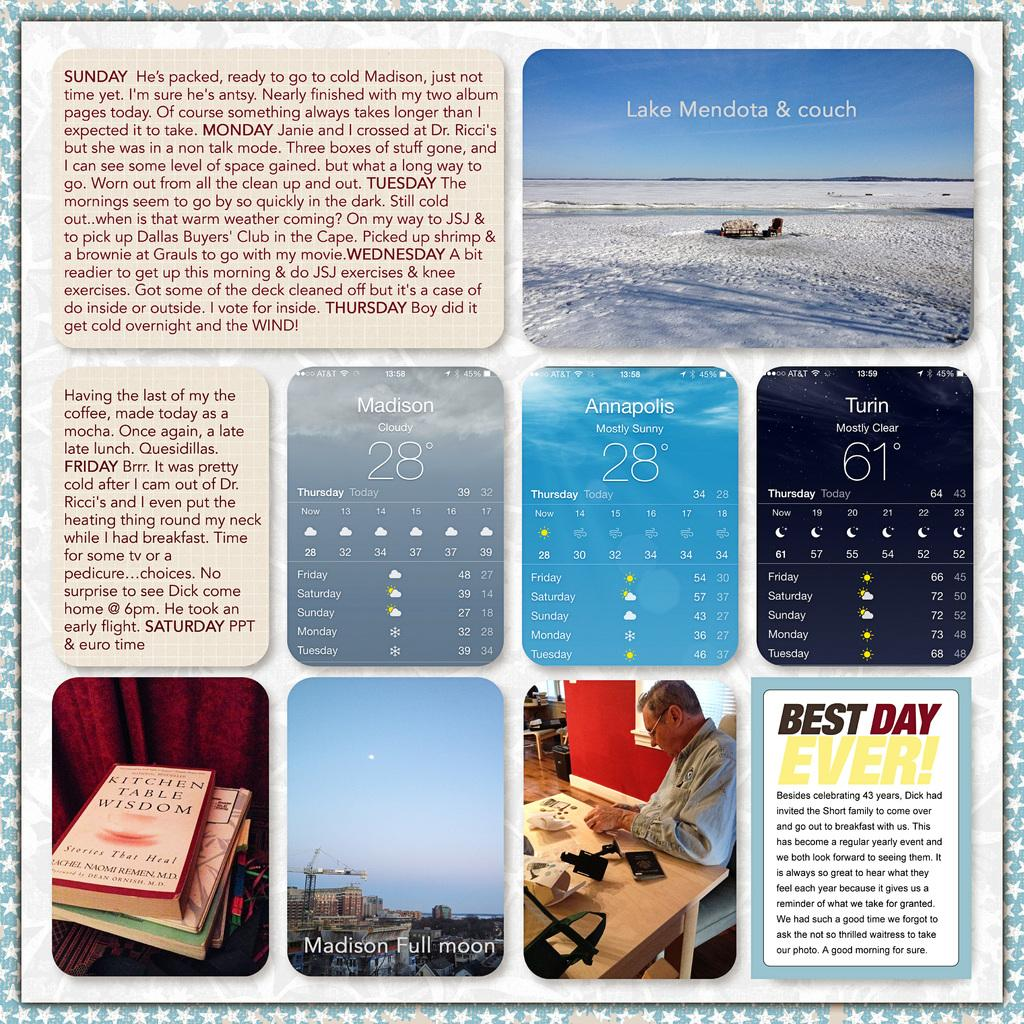<image>
Provide a brief description of the given image. A collage of pictures and diary notes has an entry that says BEST DAY EVER!. 